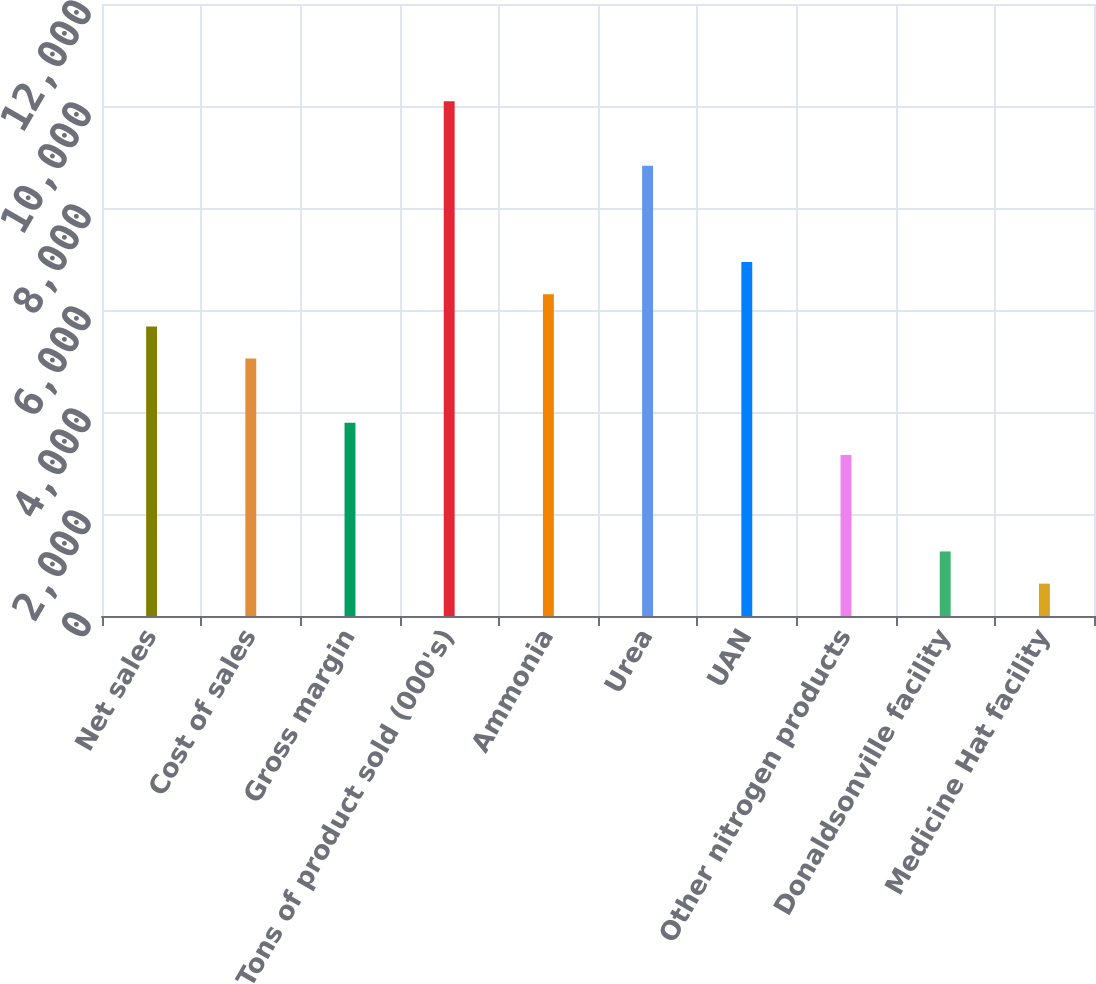Convert chart. <chart><loc_0><loc_0><loc_500><loc_500><bar_chart><fcel>Net sales<fcel>Cost of sales<fcel>Gross margin<fcel>Tons of product sold (000's)<fcel>Ammonia<fcel>Urea<fcel>UAN<fcel>Other nitrogen products<fcel>Donaldsonville facility<fcel>Medicine Hat facility<nl><fcel>5678.59<fcel>5048.16<fcel>3787.3<fcel>10091.6<fcel>6309.02<fcel>8830.74<fcel>6939.45<fcel>3156.87<fcel>1265.58<fcel>635.15<nl></chart> 